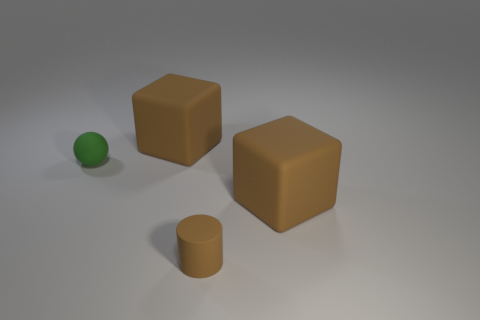Are there any matte balls of the same size as the green rubber thing?
Offer a terse response. No. There is a rubber cube that is on the left side of the small brown thing; is its color the same as the large block on the right side of the tiny brown thing?
Ensure brevity in your answer.  Yes. Is there a sphere that has the same color as the cylinder?
Your answer should be very brief. No. How many other objects are the same shape as the small brown matte thing?
Offer a terse response. 0. There is a thing that is to the right of the rubber cylinder; what is its shape?
Your answer should be very brief. Cube. Does the tiny green rubber object have the same shape as the large thing that is behind the small green ball?
Your answer should be very brief. No. There is a object that is on the right side of the tiny green ball and on the left side of the cylinder; what size is it?
Your answer should be compact. Large. What color is the matte object that is both right of the tiny green rubber object and left of the cylinder?
Make the answer very short. Brown. Are there fewer small cylinders on the left side of the small matte ball than small green things that are to the right of the tiny brown matte cylinder?
Ensure brevity in your answer.  No. Is there any other thing that has the same color as the tiny rubber sphere?
Give a very brief answer. No. 